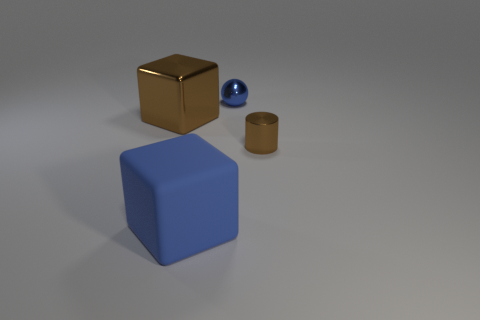Are there any other things that are the same material as the large blue thing?
Make the answer very short. No. There is a blue object in front of the brown shiny object that is on the left side of the small cylinder; what size is it?
Your answer should be very brief. Large. There is a large object that is to the left of the big blue thing; does it have the same shape as the thing that is right of the small blue object?
Your response must be concise. No. Are there the same number of brown things behind the cylinder and small cylinders?
Your response must be concise. Yes. The large matte thing that is the same shape as the big shiny object is what color?
Keep it short and to the point. Blue. Are the blue thing that is left of the ball and the sphere made of the same material?
Keep it short and to the point. No. How many large things are either brown blocks or blue blocks?
Give a very brief answer. 2. What size is the cylinder?
Offer a very short reply. Small. There is a shiny sphere; does it have the same size as the blue thing in front of the shiny cylinder?
Ensure brevity in your answer.  No. How many blue objects are either tiny balls or matte cubes?
Your answer should be very brief. 2. 